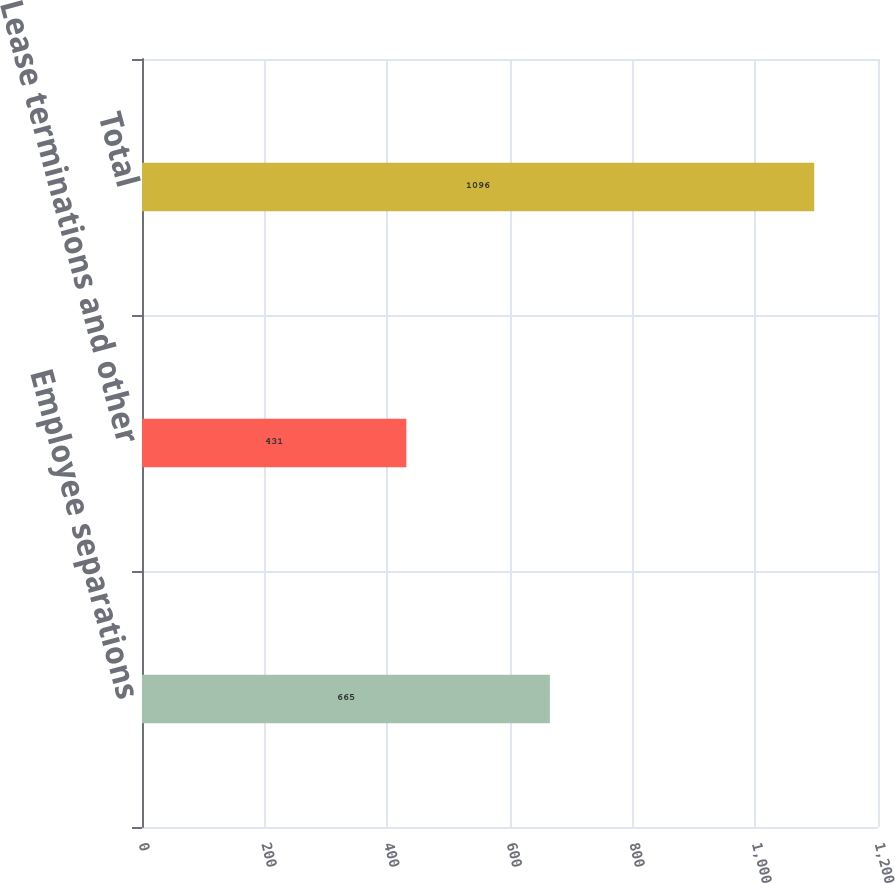<chart> <loc_0><loc_0><loc_500><loc_500><bar_chart><fcel>Employee separations<fcel>Lease terminations and other<fcel>Total<nl><fcel>665<fcel>431<fcel>1096<nl></chart> 